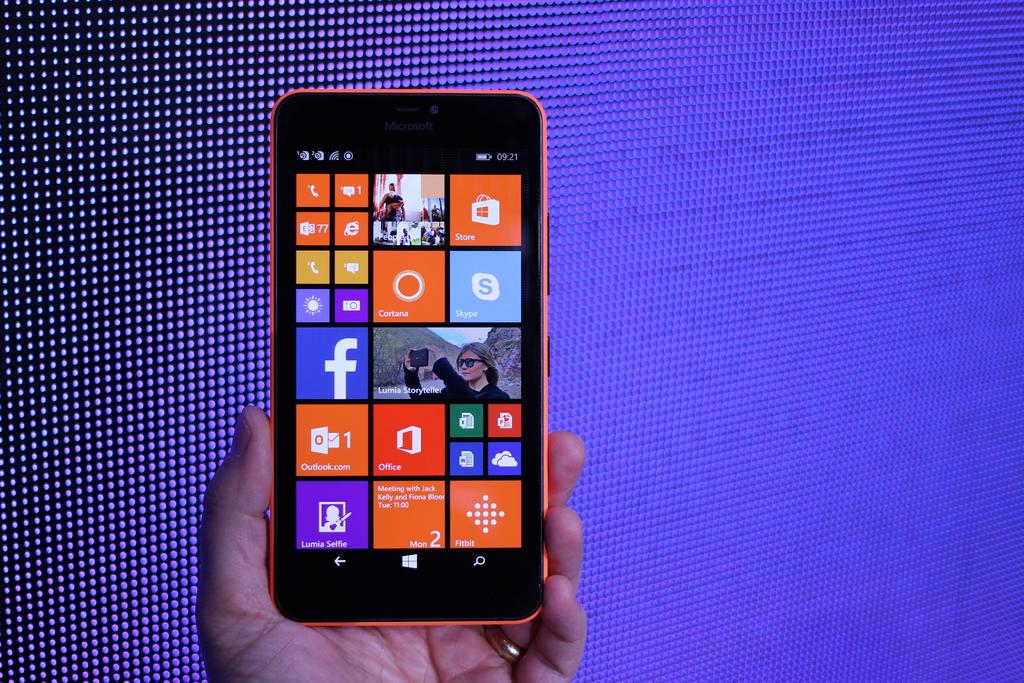Does the phone have a facebook app?
Make the answer very short. Yes. What mail app does this phone use?
Your answer should be very brief. Outlook. 